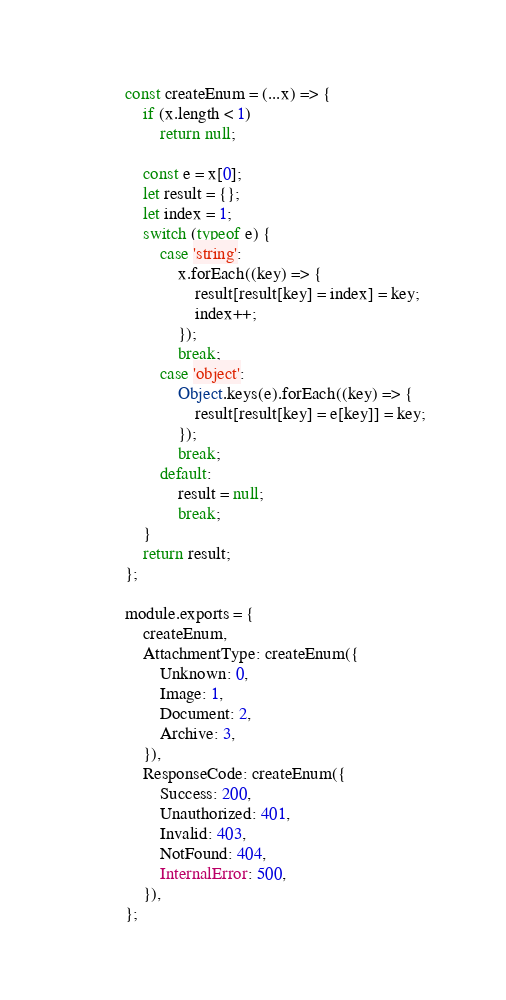<code> <loc_0><loc_0><loc_500><loc_500><_JavaScript_>const createEnum = (...x) => {
    if (x.length < 1)
        return null;

    const e = x[0];
    let result = {};
    let index = 1;
    switch (typeof e) {
        case 'string':
            x.forEach((key) => {
                result[result[key] = index] = key;
                index++;
            });
            break;
        case 'object':
            Object.keys(e).forEach((key) => {
                result[result[key] = e[key]] = key;
            });
            break;
        default:
            result = null;
            break;
    }
    return result;
};

module.exports = {
    createEnum,
    AttachmentType: createEnum({
        Unknown: 0,
        Image: 1,
        Document: 2,
        Archive: 3,
    }),
    ResponseCode: createEnum({
        Success: 200,
        Unauthorized: 401,
        Invalid: 403,
        NotFound: 404,
        InternalError: 500,
    }),
};
</code> 